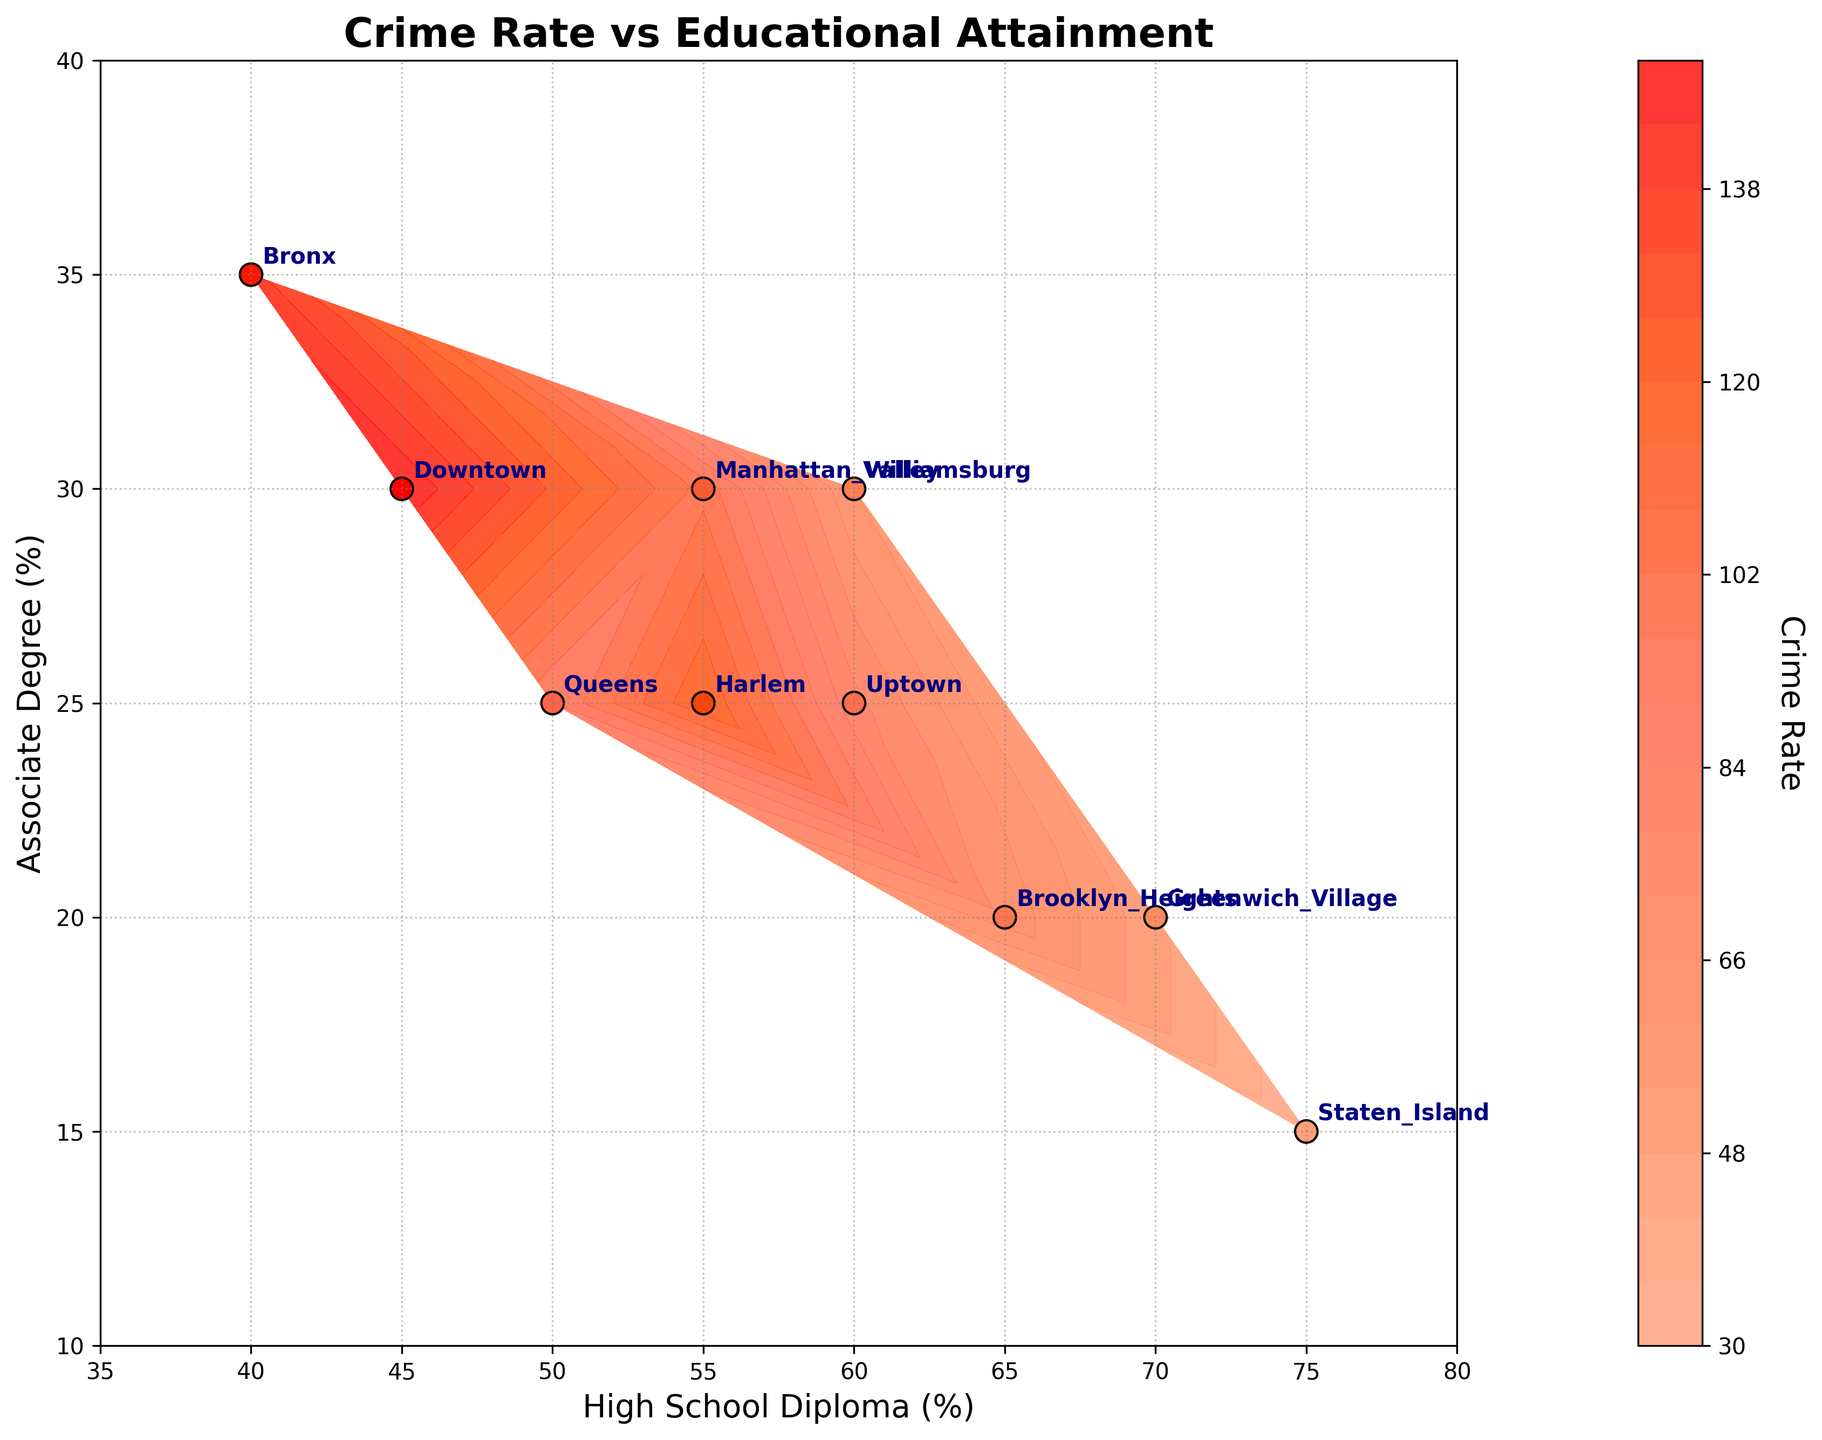What's the title of the figure? The title is located at the top of the figure, usually in a larger and bold font.
Answer: Crime Rate vs Educational Attainment What does the colorbar represent? The colorbar is located beside the plot and is labeled. It usually contains a gradient of colors indicating the variable it corresponds to, in this case, "Crime Rate."
Answer: Crime Rate Which neighborhood has the highest crime rate? By observing the scatter points and their corresponding colors, the darkest red shade indicates the highest crime rate. According to the annotations, "Downtown" has the most intense red color.
Answer: Downtown What are the x and y-axis labels? The labels are found along the respective x and y axes with descriptive text. The x-axis is labeled "High School Diploma (%)" and the y-axis is labeled "Associate Degree (%)."
Answer: High School Diploma (%) and Associate Degree (%) How many neighborhoods have a crime rate higher than 100? Look at the scatter points and find the ones with colors corresponding to crime rates above 100. Annotated neighborhoods "Downtown," "Harlem," "Bronx," and "Manhattan Valley" have shades representing crime rates higher than 100.
Answer: 4 Which neighborhood has the lowest crime rate, and what is the corresponding educational level for Associate Degree? The lightest shade on the color map represents the lowest crime rate. "Staten Island" has the lightest color indicating the lowest crime rate. The y coordinate for "Staten Island" represents its Associate Degree percentage, which is 15%.
Answer: Staten Island and 15% If a neighborhood has 50% high school graduates and 25% with associate degrees, what is its approximate crime rate? Locate the point (50, 25) on the plot and observe the color surrounding this coordinate. The color around this point corresponds to a moderate red shade, indicating 90 as the approximate crime rate.
Answer: 90 Compare the crime rates of Williamsburg and Queens. Which one is higher? Find the points annotated "Williamsburg" and "Queens." Compare their colors. Williamsburg has a lighter shade of red compared to Queens, indicating that Williamsburg has a lower crime rate than Queens.
Answer: Queens What educational levels correspond to a neighborhood with a crime rate around 70? Find the position on the plot corresponding to a color idicating 70 on the colorbar. "Brooklyn Heights" has a color indicating a crime rate of around 70. Its x and y coordinates (65, 20) are the educational levels.
Answer: 65% High School Diploma and 20% Associate Degree Which neighborhoods have approximately the same levels of educational attainment but different crime rates? Look for points with similar x and y coordinates but different colors. "Harlem" (55, 25) and "Manhattan Valley" (55, 30) both have similar educational levels but different shades, indicating different crime rates.
Answer: Harlem and Manhattan Valley 